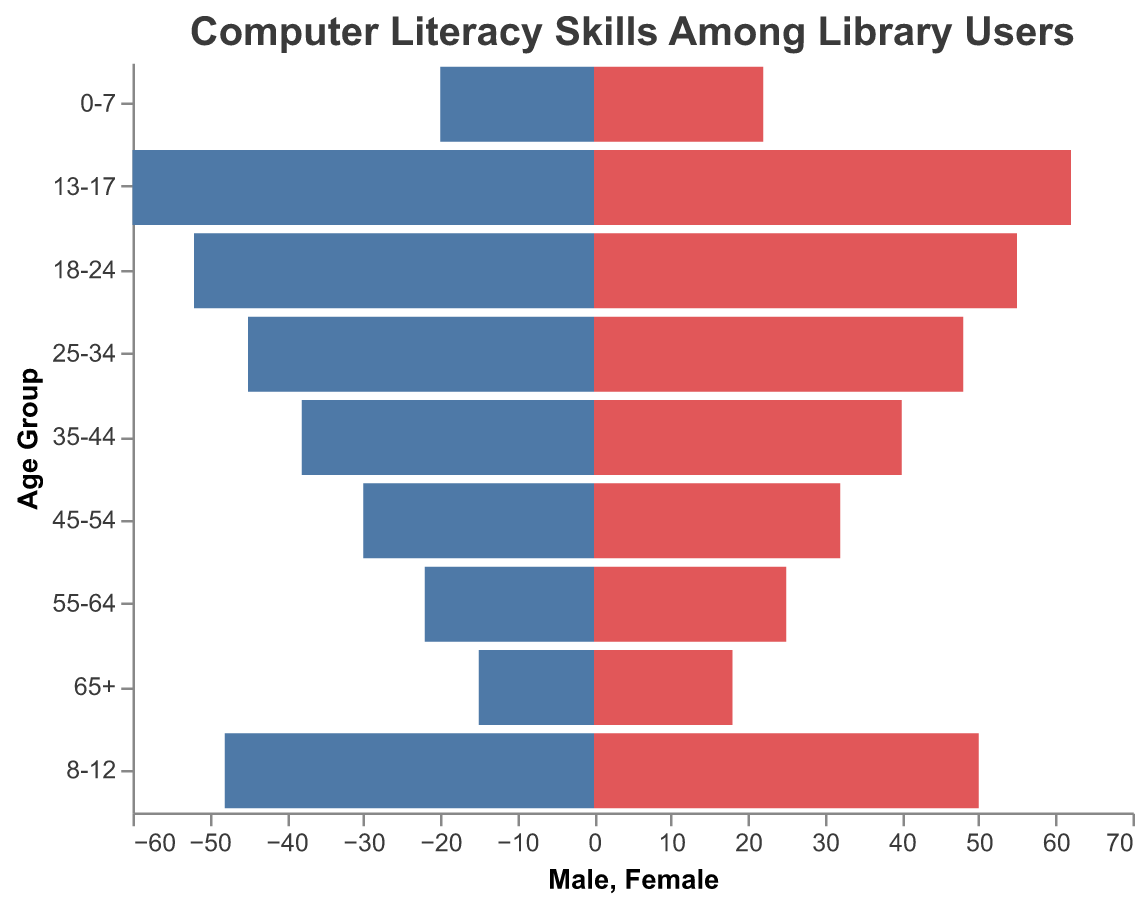What is the title of the figure? The title is displayed at the top of the figure and provides a succinct summary of the visualized data.
Answer: "Computer Literacy Skills Among Library Users" How many age groups are represented in the figure? Count the number of unique "Age Group" categories on the vertical axis. There are 9 age groups listed: "65+", "55-64", "45-54", "35-44", "25-34", "18-24", "13-17", "8-12", "0-7".
Answer: 9 Which age group has the highest number of male users? Review the bar lengths for males across all age groups and identify the longest bar. The age group "13-17" has the longest bar for males at 60.
Answer: 13-17 What is the difference between the number of female users in the 18-24 and 25-34 age groups? Find the difference between the female values for the "18-24" and "25-34" age groups. The number of females in "18-24" is 55 and in "25-34" is 48. Calculate 55 - 48.
Answer: 7 Which age group has the smallest gender gap in computer literacy skills? Calculate the absolute difference between male and female numbers for each age group and find the smallest difference. For "35-44" and "45-54", the differences are 2 each, both being the smallest gaps.
Answer: 35-44 and 45-54 Which age group has more female users than male users, and by how many? Identify the age groups where the number of females is greater than the number of males and calculate the differences. For "65+", "55-64", and "0-7", calculate the respective differences: 3, 3, and 2.
Answer: 65+ (3), 55-64 (3), 0-7 (2) What is the total number of male users across all age groups? Add the male numbers for each age group: 15 + 22 + 30 + 38 + 45 + 52 + 60 + 48 + 20. Sum these numbers to get the total.
Answer: 330 How do the computer literacy skills of users aged 18-24 compare between genders? Compare the male and female values for the "18-24" age group. The number of males is 52, and the number of females is 55.
Answer: Females have slightly higher numbers than males by 3 What is the average number of female users in the age groups under 25? Add up the female numbers for the age groups "0-7", "8-12", "13-17", and "18-24"; then divide by the number of these age groups (4). (22 + 50 + 62 + 55) / 4.
Answer: 47.25 In which age group is the difference between the number of male and female users the largest? Calculate the differences between males and females for each age group and find the largest one. The biggest difference is in the "13-17" age group, with a difference of 2.
Answer: 13-17 